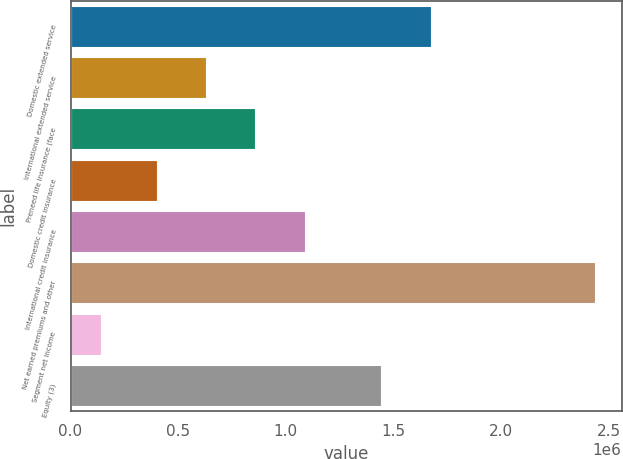Convert chart. <chart><loc_0><loc_0><loc_500><loc_500><bar_chart><fcel>Domestic extended service<fcel>International extended service<fcel>Preneed life insurance (face<fcel>Domestic credit insurance<fcel>International credit insurance<fcel>Net earned premiums and other<fcel>Segment net income<fcel>Equity (3)<nl><fcel>1.67348e+06<fcel>629249<fcel>858935<fcel>399564<fcel>1.08862e+06<fcel>2.43841e+06<fcel>141553<fcel>1.4438e+06<nl></chart> 